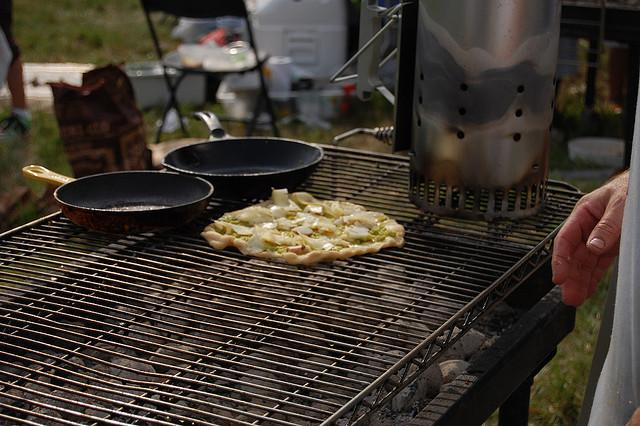Where is the item being grilled normally prepared? oven 